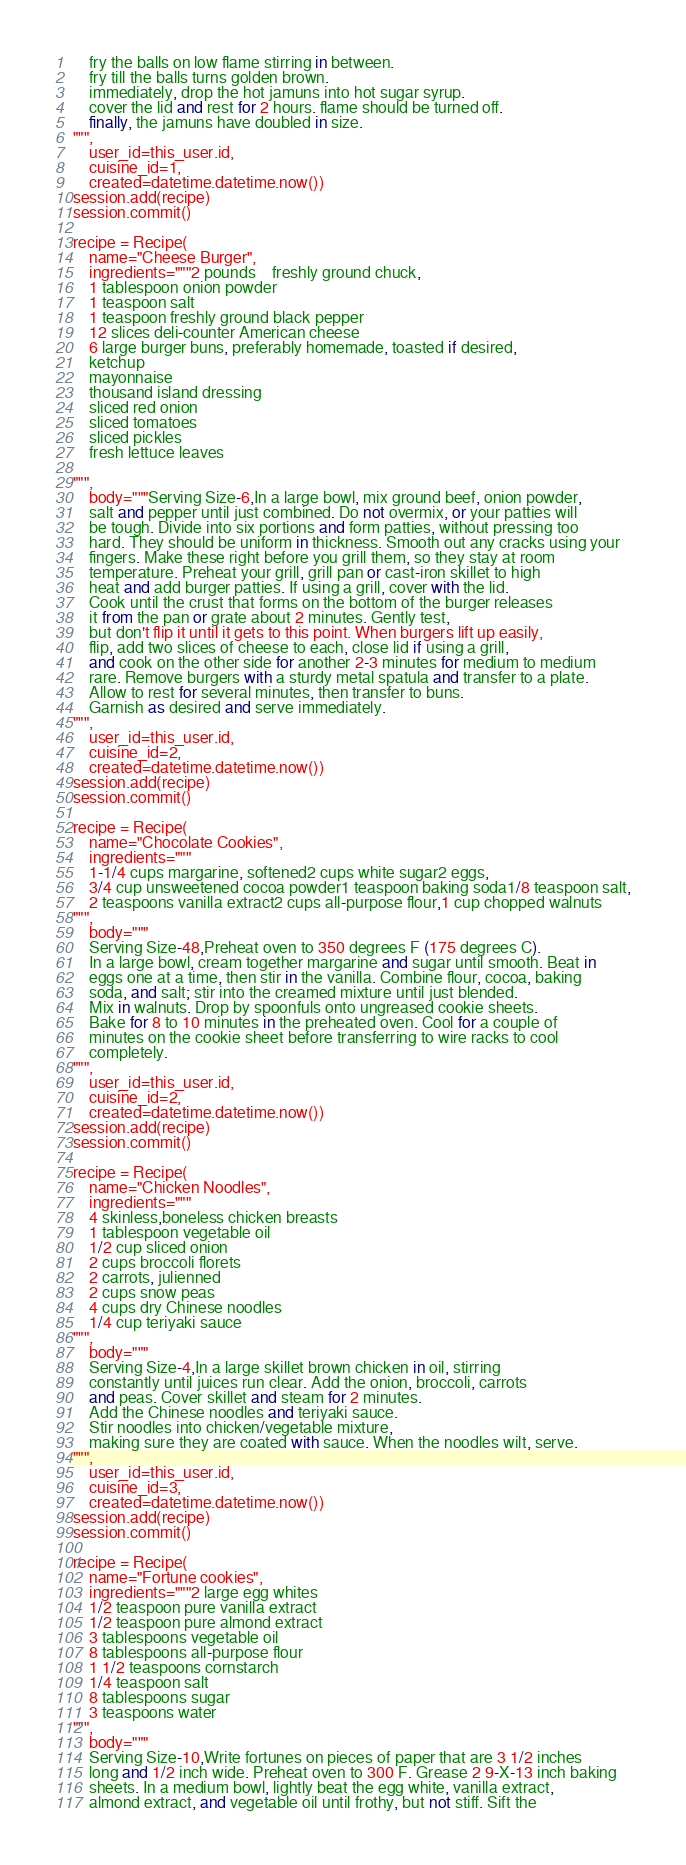Convert code to text. <code><loc_0><loc_0><loc_500><loc_500><_Python_>    fry the balls on low flame stirring in between.
    fry till the balls turns golden brown.
    immediately, drop the hot jamuns into hot sugar syrup.
    cover the lid and rest for 2 hours. flame should be turned off.
    finally, the jamuns have doubled in size.
""",
    user_id=this_user.id,
    cuisine_id=1,
    created=datetime.datetime.now())
session.add(recipe)
session.commit()

recipe = Recipe(
    name="Cheese Burger",
    ingredients="""2 pounds	freshly ground chuck,
    1 tablespoon onion powder
    1 teaspoon salt
    1 teaspoon freshly ground black pepper
    12 slices deli-counter American cheese
    6 large burger buns, preferably homemade, toasted if desired,
    ketchup
    mayonnaise
    thousand island dressing
    sliced red onion
    sliced tomatoes
    sliced pickles
    fresh lettuce leaves

""",
    body="""Serving Size-6,In a large bowl, mix ground beef, onion powder,
    salt and pepper until just combined. Do not overmix, or your patties will
    be tough. Divide into six portions and form patties, without pressing too
    hard. They should be uniform in thickness. Smooth out any cracks using your
    fingers. Make these right before you grill them, so they stay at room
    temperature. Preheat your grill, grill pan or cast-iron skillet to high
    heat and add burger patties. If using a grill, cover with the lid.
    Cook until the crust that forms on the bottom of the burger releases
    it from the pan or grate about 2 minutes. Gently test,
    but don't flip it until it gets to this point. When burgers lift up easily,
    flip, add two slices of cheese to each, close lid if using a grill,
    and cook on the other side for another 2-3 minutes for medium to medium
    rare. Remove burgers with a sturdy metal spatula and transfer to a plate.
    Allow to rest for several minutes, then transfer to buns.
    Garnish as desired and serve immediately.
""",
    user_id=this_user.id,
    cuisine_id=2,
    created=datetime.datetime.now())
session.add(recipe)
session.commit()

recipe = Recipe(
    name="Chocolate Cookies",
    ingredients="""
    1-1/4 cups margarine, softened2 cups white sugar2 eggs,
    3/4 cup unsweetened cocoa powder1 teaspoon baking soda1/8 teaspoon salt,
    2 teaspoons vanilla extract2 cups all-purpose flour,1 cup chopped walnuts
""",
    body="""
    Serving Size-48,Preheat oven to 350 degrees F (175 degrees C).
    In a large bowl, cream together margarine and sugar until smooth. Beat in
    eggs one at a time, then stir in the vanilla. Combine flour, cocoa, baking
    soda, and salt; stir into the creamed mixture until just blended.
    Mix in walnuts. Drop by spoonfuls onto ungreased cookie sheets.
    Bake for 8 to 10 minutes in the preheated oven. Cool for a couple of
    minutes on the cookie sheet before transferring to wire racks to cool
    completely.
""",
    user_id=this_user.id,
    cuisine_id=2,
    created=datetime.datetime.now())
session.add(recipe)
session.commit()

recipe = Recipe(
    name="Chicken Noodles",
    ingredients="""
    4 skinless,boneless chicken breasts
    1 tablespoon vegetable oil
    1/2 cup sliced onion
    2 cups broccoli florets
    2 carrots, julienned
    2 cups snow peas
    4 cups dry Chinese noodles
    1/4 cup teriyaki sauce
""",
    body="""
    Serving Size-4,In a large skillet brown chicken in oil, stirring
    constantly until juices run clear. Add the onion, broccoli, carrots
    and peas. Cover skillet and steam for 2 minutes.
    Add the Chinese noodles and teriyaki sauce.
    Stir noodles into chicken/vegetable mixture,
    making sure they are coated with sauce. When the noodles wilt, serve.
""",
    user_id=this_user.id,
    cuisine_id=3,
    created=datetime.datetime.now())
session.add(recipe)
session.commit()

recipe = Recipe(
    name="Fortune cookies",
    ingredients="""2 large egg whites
    1/2 teaspoon pure vanilla extract
    1/2 teaspoon pure almond extract
    3 tablespoons vegetable oil
    8 tablespoons all-purpose flour
    1 1/2 teaspoons cornstarch
    1/4 teaspoon salt
    8 tablespoons sugar
    3 teaspoons water
""",
    body="""
    Serving Size-10,Write fortunes on pieces of paper that are 3 1/2 inches
    long and 1/2 inch wide. Preheat oven to 300 F. Grease 2 9-X-13 inch baking
    sheets. In a medium bowl, lightly beat the egg white, vanilla extract,
    almond extract, and vegetable oil until frothy, but not stiff. Sift the</code> 